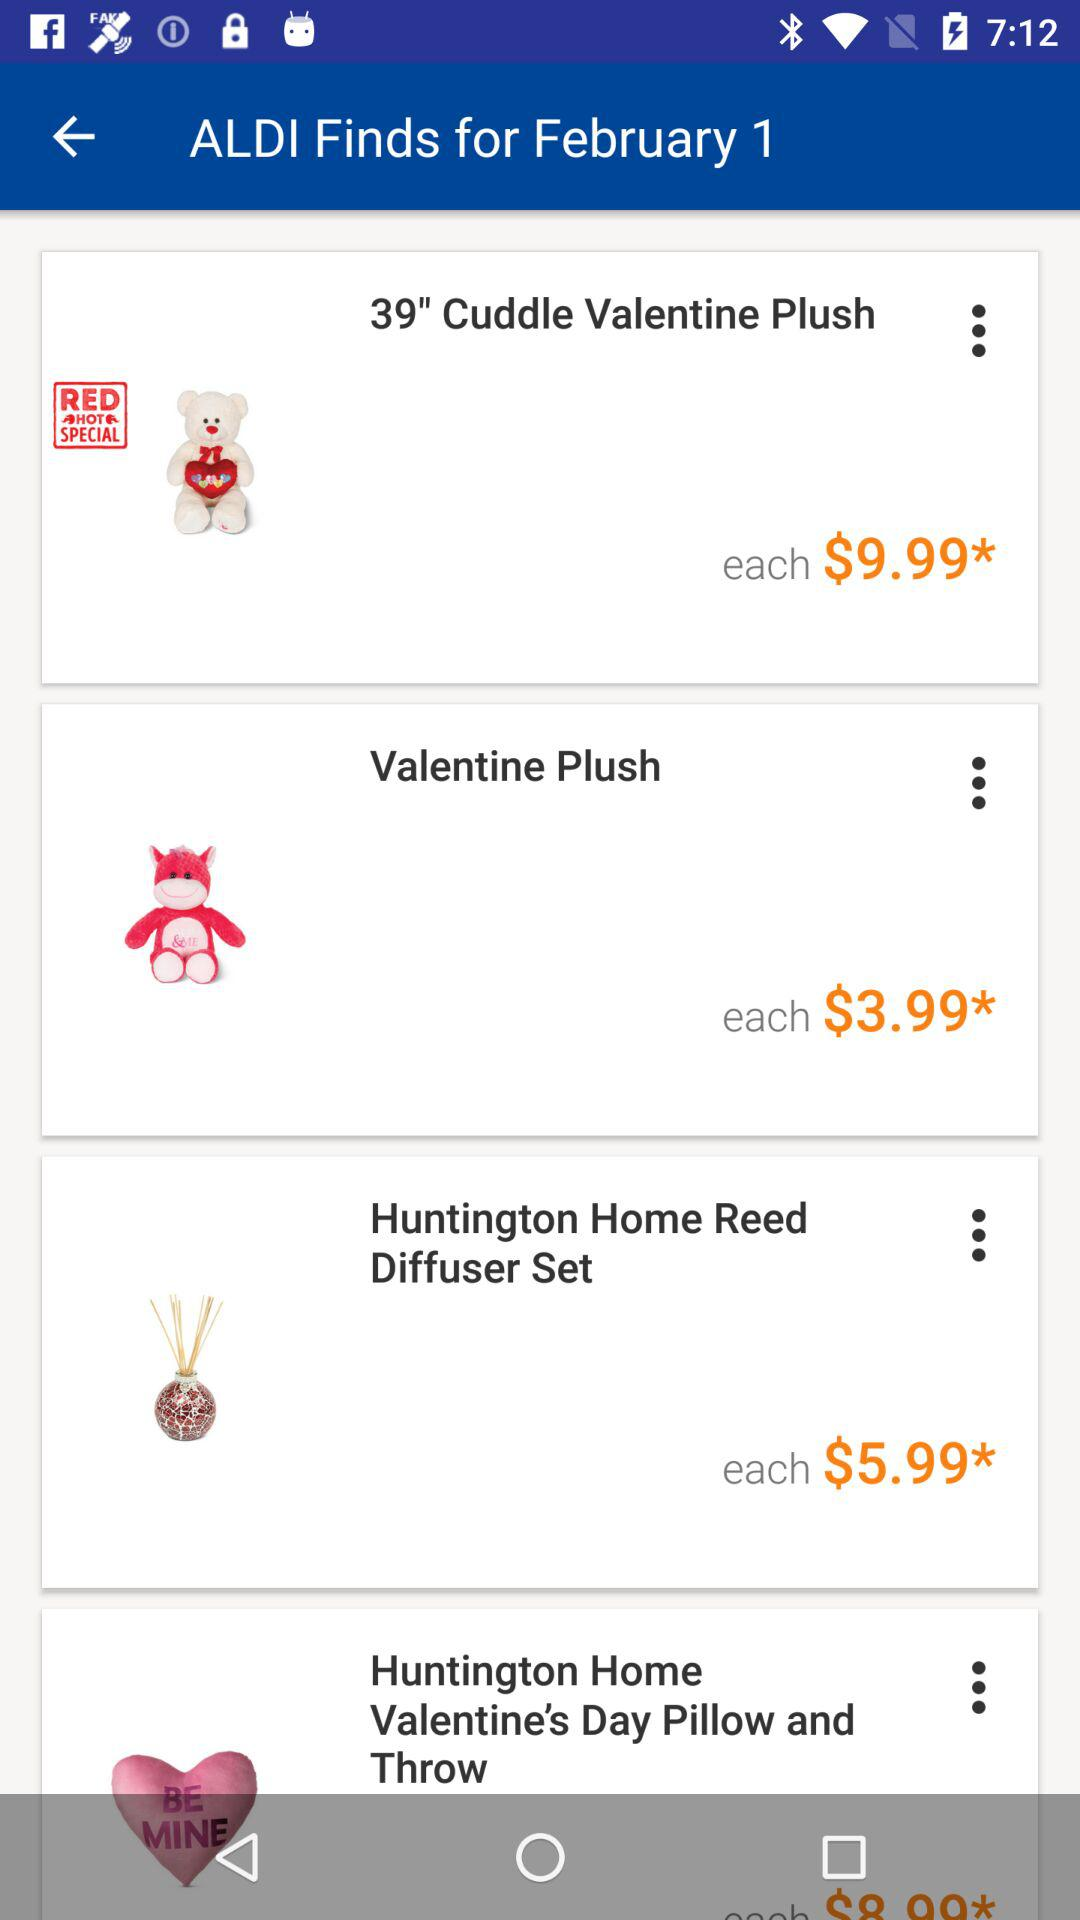What is the size of the "Cuddle Valentine Plush"? The size of the "Cuddle Valentine Plush" is 39". 